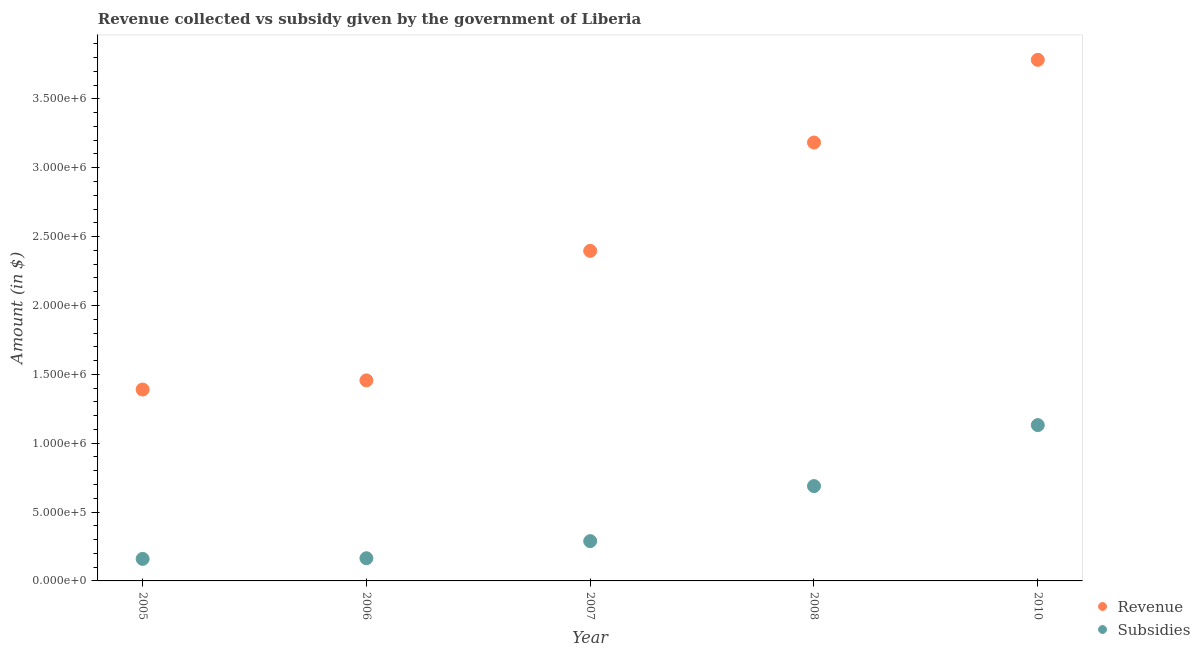What is the amount of revenue collected in 2005?
Make the answer very short. 1.39e+06. Across all years, what is the maximum amount of revenue collected?
Your answer should be compact. 3.78e+06. Across all years, what is the minimum amount of subsidies given?
Keep it short and to the point. 1.60e+05. What is the total amount of subsidies given in the graph?
Your response must be concise. 2.43e+06. What is the difference between the amount of subsidies given in 2008 and that in 2010?
Ensure brevity in your answer.  -4.43e+05. What is the difference between the amount of revenue collected in 2008 and the amount of subsidies given in 2005?
Ensure brevity in your answer.  3.02e+06. What is the average amount of revenue collected per year?
Make the answer very short. 2.44e+06. In the year 2005, what is the difference between the amount of subsidies given and amount of revenue collected?
Provide a short and direct response. -1.23e+06. What is the ratio of the amount of revenue collected in 2006 to that in 2008?
Offer a terse response. 0.46. Is the amount of revenue collected in 2006 less than that in 2010?
Provide a succinct answer. Yes. Is the difference between the amount of revenue collected in 2005 and 2006 greater than the difference between the amount of subsidies given in 2005 and 2006?
Keep it short and to the point. No. What is the difference between the highest and the second highest amount of revenue collected?
Provide a succinct answer. 6.00e+05. What is the difference between the highest and the lowest amount of subsidies given?
Ensure brevity in your answer.  9.71e+05. Is the sum of the amount of subsidies given in 2008 and 2010 greater than the maximum amount of revenue collected across all years?
Keep it short and to the point. No. Does the amount of revenue collected monotonically increase over the years?
Provide a succinct answer. Yes. Is the amount of revenue collected strictly greater than the amount of subsidies given over the years?
Provide a short and direct response. Yes. How many dotlines are there?
Make the answer very short. 2. How many years are there in the graph?
Offer a terse response. 5. Where does the legend appear in the graph?
Give a very brief answer. Bottom right. How many legend labels are there?
Your response must be concise. 2. How are the legend labels stacked?
Keep it short and to the point. Vertical. What is the title of the graph?
Keep it short and to the point. Revenue collected vs subsidy given by the government of Liberia. Does "Residents" appear as one of the legend labels in the graph?
Provide a succinct answer. No. What is the label or title of the X-axis?
Give a very brief answer. Year. What is the label or title of the Y-axis?
Make the answer very short. Amount (in $). What is the Amount (in $) in Revenue in 2005?
Give a very brief answer. 1.39e+06. What is the Amount (in $) in Subsidies in 2005?
Offer a very short reply. 1.60e+05. What is the Amount (in $) in Revenue in 2006?
Give a very brief answer. 1.46e+06. What is the Amount (in $) of Subsidies in 2006?
Give a very brief answer. 1.65e+05. What is the Amount (in $) in Revenue in 2007?
Make the answer very short. 2.40e+06. What is the Amount (in $) of Subsidies in 2007?
Provide a short and direct response. 2.89e+05. What is the Amount (in $) in Revenue in 2008?
Offer a terse response. 3.18e+06. What is the Amount (in $) of Subsidies in 2008?
Your response must be concise. 6.89e+05. What is the Amount (in $) of Revenue in 2010?
Give a very brief answer. 3.78e+06. What is the Amount (in $) of Subsidies in 2010?
Provide a short and direct response. 1.13e+06. Across all years, what is the maximum Amount (in $) of Revenue?
Offer a terse response. 3.78e+06. Across all years, what is the maximum Amount (in $) in Subsidies?
Provide a succinct answer. 1.13e+06. Across all years, what is the minimum Amount (in $) of Revenue?
Provide a short and direct response. 1.39e+06. Across all years, what is the minimum Amount (in $) of Subsidies?
Your answer should be compact. 1.60e+05. What is the total Amount (in $) of Revenue in the graph?
Provide a succinct answer. 1.22e+07. What is the total Amount (in $) of Subsidies in the graph?
Make the answer very short. 2.43e+06. What is the difference between the Amount (in $) in Revenue in 2005 and that in 2006?
Your answer should be compact. -6.64e+04. What is the difference between the Amount (in $) of Subsidies in 2005 and that in 2006?
Keep it short and to the point. -4671.72. What is the difference between the Amount (in $) in Revenue in 2005 and that in 2007?
Provide a succinct answer. -1.01e+06. What is the difference between the Amount (in $) of Subsidies in 2005 and that in 2007?
Your answer should be compact. -1.29e+05. What is the difference between the Amount (in $) in Revenue in 2005 and that in 2008?
Offer a very short reply. -1.79e+06. What is the difference between the Amount (in $) in Subsidies in 2005 and that in 2008?
Offer a terse response. -5.29e+05. What is the difference between the Amount (in $) in Revenue in 2005 and that in 2010?
Your response must be concise. -2.39e+06. What is the difference between the Amount (in $) of Subsidies in 2005 and that in 2010?
Give a very brief answer. -9.71e+05. What is the difference between the Amount (in $) of Revenue in 2006 and that in 2007?
Give a very brief answer. -9.40e+05. What is the difference between the Amount (in $) of Subsidies in 2006 and that in 2007?
Keep it short and to the point. -1.24e+05. What is the difference between the Amount (in $) of Revenue in 2006 and that in 2008?
Make the answer very short. -1.73e+06. What is the difference between the Amount (in $) in Subsidies in 2006 and that in 2008?
Give a very brief answer. -5.24e+05. What is the difference between the Amount (in $) in Revenue in 2006 and that in 2010?
Your response must be concise. -2.33e+06. What is the difference between the Amount (in $) in Subsidies in 2006 and that in 2010?
Keep it short and to the point. -9.67e+05. What is the difference between the Amount (in $) in Revenue in 2007 and that in 2008?
Provide a short and direct response. -7.87e+05. What is the difference between the Amount (in $) in Subsidies in 2007 and that in 2008?
Your answer should be compact. -4.00e+05. What is the difference between the Amount (in $) of Revenue in 2007 and that in 2010?
Your answer should be compact. -1.39e+06. What is the difference between the Amount (in $) of Subsidies in 2007 and that in 2010?
Offer a very short reply. -8.42e+05. What is the difference between the Amount (in $) of Revenue in 2008 and that in 2010?
Offer a terse response. -6.00e+05. What is the difference between the Amount (in $) in Subsidies in 2008 and that in 2010?
Your response must be concise. -4.43e+05. What is the difference between the Amount (in $) of Revenue in 2005 and the Amount (in $) of Subsidies in 2006?
Offer a terse response. 1.23e+06. What is the difference between the Amount (in $) of Revenue in 2005 and the Amount (in $) of Subsidies in 2007?
Give a very brief answer. 1.10e+06. What is the difference between the Amount (in $) in Revenue in 2005 and the Amount (in $) in Subsidies in 2008?
Give a very brief answer. 7.01e+05. What is the difference between the Amount (in $) in Revenue in 2005 and the Amount (in $) in Subsidies in 2010?
Offer a very short reply. 2.58e+05. What is the difference between the Amount (in $) in Revenue in 2006 and the Amount (in $) in Subsidies in 2007?
Your answer should be very brief. 1.17e+06. What is the difference between the Amount (in $) of Revenue in 2006 and the Amount (in $) of Subsidies in 2008?
Provide a short and direct response. 7.67e+05. What is the difference between the Amount (in $) of Revenue in 2006 and the Amount (in $) of Subsidies in 2010?
Make the answer very short. 3.25e+05. What is the difference between the Amount (in $) in Revenue in 2007 and the Amount (in $) in Subsidies in 2008?
Keep it short and to the point. 1.71e+06. What is the difference between the Amount (in $) in Revenue in 2007 and the Amount (in $) in Subsidies in 2010?
Provide a short and direct response. 1.27e+06. What is the difference between the Amount (in $) in Revenue in 2008 and the Amount (in $) in Subsidies in 2010?
Provide a succinct answer. 2.05e+06. What is the average Amount (in $) of Revenue per year?
Your answer should be compact. 2.44e+06. What is the average Amount (in $) in Subsidies per year?
Provide a short and direct response. 4.87e+05. In the year 2005, what is the difference between the Amount (in $) in Revenue and Amount (in $) in Subsidies?
Provide a short and direct response. 1.23e+06. In the year 2006, what is the difference between the Amount (in $) in Revenue and Amount (in $) in Subsidies?
Keep it short and to the point. 1.29e+06. In the year 2007, what is the difference between the Amount (in $) in Revenue and Amount (in $) in Subsidies?
Make the answer very short. 2.11e+06. In the year 2008, what is the difference between the Amount (in $) in Revenue and Amount (in $) in Subsidies?
Your response must be concise. 2.49e+06. In the year 2010, what is the difference between the Amount (in $) of Revenue and Amount (in $) of Subsidies?
Your answer should be compact. 2.65e+06. What is the ratio of the Amount (in $) in Revenue in 2005 to that in 2006?
Provide a short and direct response. 0.95. What is the ratio of the Amount (in $) in Subsidies in 2005 to that in 2006?
Your answer should be compact. 0.97. What is the ratio of the Amount (in $) of Revenue in 2005 to that in 2007?
Give a very brief answer. 0.58. What is the ratio of the Amount (in $) of Subsidies in 2005 to that in 2007?
Offer a very short reply. 0.55. What is the ratio of the Amount (in $) of Revenue in 2005 to that in 2008?
Offer a very short reply. 0.44. What is the ratio of the Amount (in $) in Subsidies in 2005 to that in 2008?
Provide a short and direct response. 0.23. What is the ratio of the Amount (in $) in Revenue in 2005 to that in 2010?
Your answer should be compact. 0.37. What is the ratio of the Amount (in $) of Subsidies in 2005 to that in 2010?
Ensure brevity in your answer.  0.14. What is the ratio of the Amount (in $) in Revenue in 2006 to that in 2007?
Offer a very short reply. 0.61. What is the ratio of the Amount (in $) in Subsidies in 2006 to that in 2007?
Make the answer very short. 0.57. What is the ratio of the Amount (in $) of Revenue in 2006 to that in 2008?
Provide a succinct answer. 0.46. What is the ratio of the Amount (in $) in Subsidies in 2006 to that in 2008?
Your answer should be very brief. 0.24. What is the ratio of the Amount (in $) in Revenue in 2006 to that in 2010?
Keep it short and to the point. 0.38. What is the ratio of the Amount (in $) of Subsidies in 2006 to that in 2010?
Make the answer very short. 0.15. What is the ratio of the Amount (in $) in Revenue in 2007 to that in 2008?
Provide a short and direct response. 0.75. What is the ratio of the Amount (in $) in Subsidies in 2007 to that in 2008?
Provide a succinct answer. 0.42. What is the ratio of the Amount (in $) in Revenue in 2007 to that in 2010?
Provide a short and direct response. 0.63. What is the ratio of the Amount (in $) in Subsidies in 2007 to that in 2010?
Your response must be concise. 0.26. What is the ratio of the Amount (in $) in Revenue in 2008 to that in 2010?
Your answer should be very brief. 0.84. What is the ratio of the Amount (in $) in Subsidies in 2008 to that in 2010?
Give a very brief answer. 0.61. What is the difference between the highest and the second highest Amount (in $) in Revenue?
Offer a very short reply. 6.00e+05. What is the difference between the highest and the second highest Amount (in $) in Subsidies?
Keep it short and to the point. 4.43e+05. What is the difference between the highest and the lowest Amount (in $) of Revenue?
Your answer should be very brief. 2.39e+06. What is the difference between the highest and the lowest Amount (in $) of Subsidies?
Provide a short and direct response. 9.71e+05. 